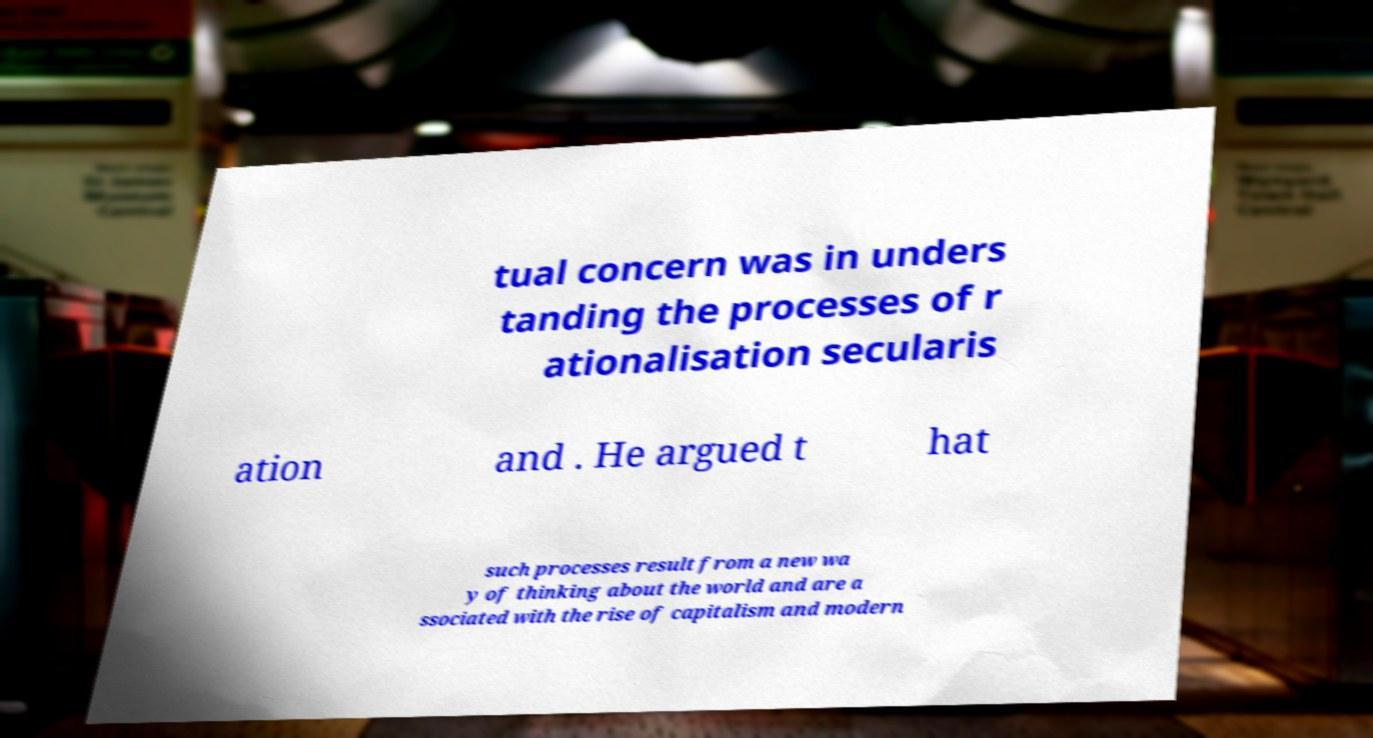I need the written content from this picture converted into text. Can you do that? tual concern was in unders tanding the processes of r ationalisation secularis ation and . He argued t hat such processes result from a new wa y of thinking about the world and are a ssociated with the rise of capitalism and modern 